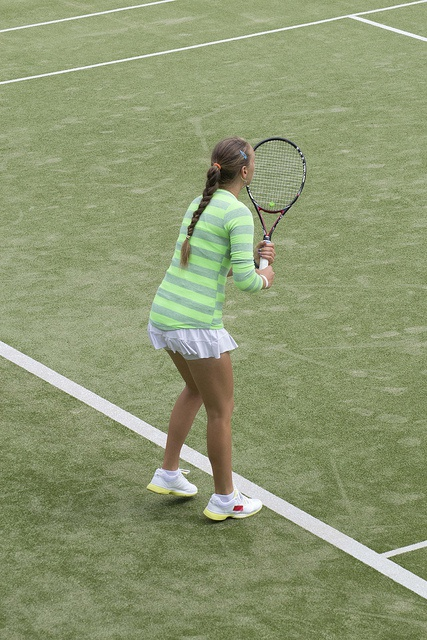Describe the objects in this image and their specific colors. I can see people in tan, lightgreen, darkgray, maroon, and gray tones and tennis racket in tan, olive, darkgray, and gray tones in this image. 